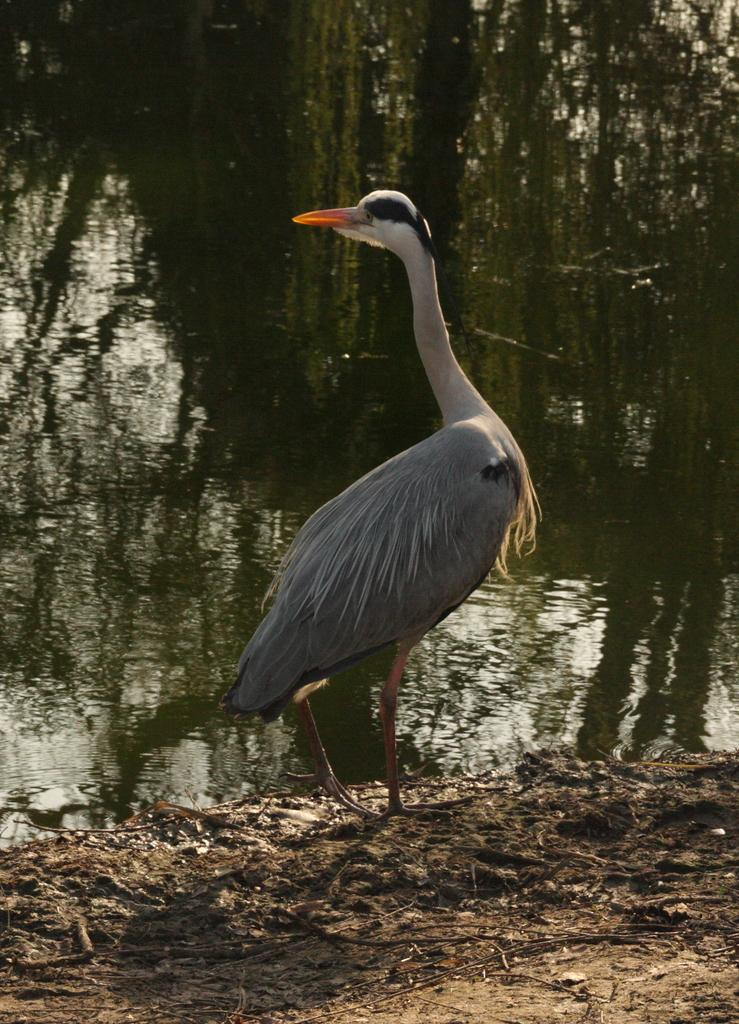What type of bird is in the center of the image? There is a great blue heron in the center of the image. What can be seen in the background of the image? Water and trees are visible in the background of the image. What is visible at the bottom of the image? The ground is visible at the bottom of the image. How many cattle can be seen grazing in the image? There are no cattle present in the image. What is the elbow of the great blue heron doing in the image? The great blue heron does not have an elbow, as it is a bird, and birds have wings instead. 